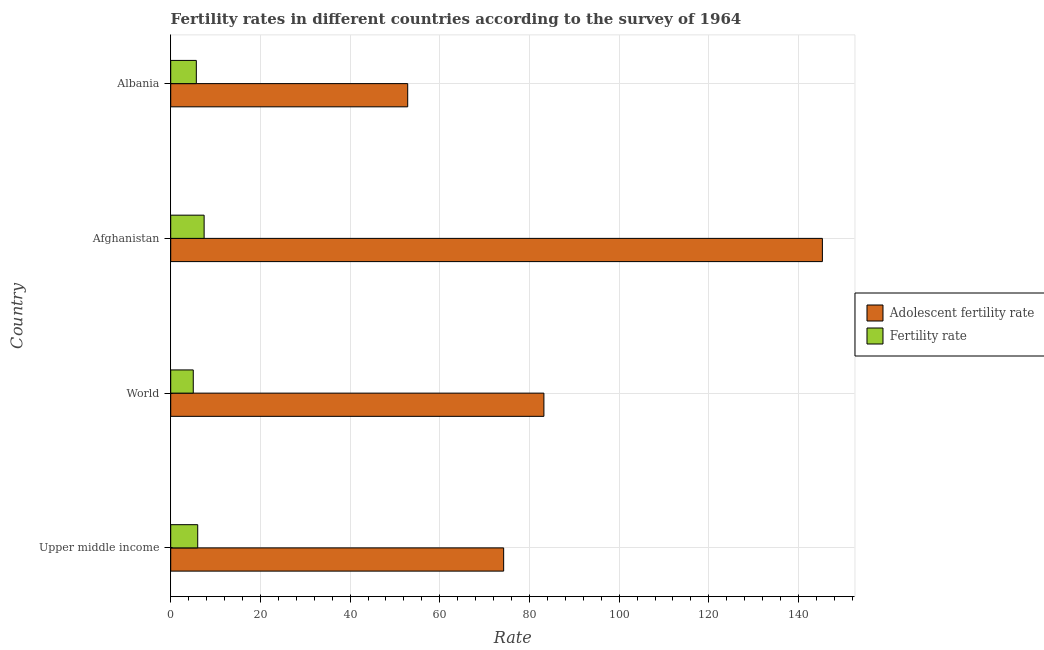How many different coloured bars are there?
Offer a terse response. 2. Are the number of bars per tick equal to the number of legend labels?
Your answer should be compact. Yes. What is the label of the 4th group of bars from the top?
Your answer should be compact. Upper middle income. What is the fertility rate in Albania?
Make the answer very short. 5.71. Across all countries, what is the maximum fertility rate?
Offer a terse response. 7.45. Across all countries, what is the minimum fertility rate?
Keep it short and to the point. 5.03. In which country was the fertility rate maximum?
Keep it short and to the point. Afghanistan. What is the total adolescent fertility rate in the graph?
Provide a short and direct response. 355.63. What is the difference between the adolescent fertility rate in Afghanistan and that in Upper middle income?
Give a very brief answer. 71.08. What is the difference between the fertility rate in World and the adolescent fertility rate in Albania?
Provide a succinct answer. -47.82. What is the average adolescent fertility rate per country?
Your answer should be very brief. 88.91. What is the difference between the fertility rate and adolescent fertility rate in Albania?
Keep it short and to the point. -47.13. What is the ratio of the adolescent fertility rate in Albania to that in World?
Give a very brief answer. 0.64. What is the difference between the highest and the second highest fertility rate?
Provide a short and direct response. 1.43. What is the difference between the highest and the lowest adolescent fertility rate?
Keep it short and to the point. 92.48. In how many countries, is the fertility rate greater than the average fertility rate taken over all countries?
Make the answer very short. 1. Is the sum of the fertility rate in Albania and World greater than the maximum adolescent fertility rate across all countries?
Offer a terse response. No. What does the 1st bar from the top in Albania represents?
Provide a short and direct response. Fertility rate. What does the 2nd bar from the bottom in Upper middle income represents?
Make the answer very short. Fertility rate. How many bars are there?
Offer a very short reply. 8. Are all the bars in the graph horizontal?
Keep it short and to the point. Yes. Does the graph contain any zero values?
Provide a short and direct response. No. How many legend labels are there?
Keep it short and to the point. 2. How are the legend labels stacked?
Your answer should be very brief. Vertical. What is the title of the graph?
Your answer should be very brief. Fertility rates in different countries according to the survey of 1964. Does "Register a property" appear as one of the legend labels in the graph?
Provide a succinct answer. No. What is the label or title of the X-axis?
Give a very brief answer. Rate. What is the label or title of the Y-axis?
Ensure brevity in your answer.  Country. What is the Rate in Adolescent fertility rate in Upper middle income?
Your answer should be very brief. 74.24. What is the Rate in Fertility rate in Upper middle income?
Offer a very short reply. 6.02. What is the Rate in Adolescent fertility rate in World?
Make the answer very short. 83.22. What is the Rate in Fertility rate in World?
Provide a short and direct response. 5.03. What is the Rate in Adolescent fertility rate in Afghanistan?
Offer a very short reply. 145.32. What is the Rate in Fertility rate in Afghanistan?
Offer a very short reply. 7.45. What is the Rate of Adolescent fertility rate in Albania?
Give a very brief answer. 52.85. What is the Rate in Fertility rate in Albania?
Offer a terse response. 5.71. Across all countries, what is the maximum Rate of Adolescent fertility rate?
Offer a terse response. 145.32. Across all countries, what is the maximum Rate of Fertility rate?
Ensure brevity in your answer.  7.45. Across all countries, what is the minimum Rate in Adolescent fertility rate?
Ensure brevity in your answer.  52.85. Across all countries, what is the minimum Rate of Fertility rate?
Your answer should be compact. 5.03. What is the total Rate of Adolescent fertility rate in the graph?
Give a very brief answer. 355.63. What is the total Rate of Fertility rate in the graph?
Provide a short and direct response. 24.21. What is the difference between the Rate in Adolescent fertility rate in Upper middle income and that in World?
Make the answer very short. -8.97. What is the difference between the Rate of Adolescent fertility rate in Upper middle income and that in Afghanistan?
Your answer should be very brief. -71.08. What is the difference between the Rate in Fertility rate in Upper middle income and that in Afghanistan?
Offer a terse response. -1.43. What is the difference between the Rate of Adolescent fertility rate in Upper middle income and that in Albania?
Your answer should be very brief. 21.4. What is the difference between the Rate of Fertility rate in Upper middle income and that in Albania?
Give a very brief answer. 0.31. What is the difference between the Rate of Adolescent fertility rate in World and that in Afghanistan?
Make the answer very short. -62.1. What is the difference between the Rate in Fertility rate in World and that in Afghanistan?
Provide a succinct answer. -2.42. What is the difference between the Rate in Adolescent fertility rate in World and that in Albania?
Offer a very short reply. 30.37. What is the difference between the Rate in Fertility rate in World and that in Albania?
Your answer should be very brief. -0.68. What is the difference between the Rate of Adolescent fertility rate in Afghanistan and that in Albania?
Provide a succinct answer. 92.47. What is the difference between the Rate of Fertility rate in Afghanistan and that in Albania?
Your response must be concise. 1.74. What is the difference between the Rate of Adolescent fertility rate in Upper middle income and the Rate of Fertility rate in World?
Provide a short and direct response. 69.22. What is the difference between the Rate in Adolescent fertility rate in Upper middle income and the Rate in Fertility rate in Afghanistan?
Your answer should be very brief. 66.79. What is the difference between the Rate of Adolescent fertility rate in Upper middle income and the Rate of Fertility rate in Albania?
Offer a terse response. 68.53. What is the difference between the Rate in Adolescent fertility rate in World and the Rate in Fertility rate in Afghanistan?
Provide a succinct answer. 75.77. What is the difference between the Rate of Adolescent fertility rate in World and the Rate of Fertility rate in Albania?
Your answer should be compact. 77.51. What is the difference between the Rate in Adolescent fertility rate in Afghanistan and the Rate in Fertility rate in Albania?
Offer a very short reply. 139.61. What is the average Rate in Adolescent fertility rate per country?
Offer a very short reply. 88.91. What is the average Rate in Fertility rate per country?
Offer a very short reply. 6.05. What is the difference between the Rate in Adolescent fertility rate and Rate in Fertility rate in Upper middle income?
Provide a succinct answer. 68.22. What is the difference between the Rate of Adolescent fertility rate and Rate of Fertility rate in World?
Your answer should be compact. 78.19. What is the difference between the Rate in Adolescent fertility rate and Rate in Fertility rate in Afghanistan?
Give a very brief answer. 137.87. What is the difference between the Rate in Adolescent fertility rate and Rate in Fertility rate in Albania?
Offer a very short reply. 47.13. What is the ratio of the Rate of Adolescent fertility rate in Upper middle income to that in World?
Keep it short and to the point. 0.89. What is the ratio of the Rate of Fertility rate in Upper middle income to that in World?
Give a very brief answer. 1.2. What is the ratio of the Rate of Adolescent fertility rate in Upper middle income to that in Afghanistan?
Make the answer very short. 0.51. What is the ratio of the Rate of Fertility rate in Upper middle income to that in Afghanistan?
Provide a succinct answer. 0.81. What is the ratio of the Rate of Adolescent fertility rate in Upper middle income to that in Albania?
Offer a very short reply. 1.4. What is the ratio of the Rate of Fertility rate in Upper middle income to that in Albania?
Your answer should be compact. 1.05. What is the ratio of the Rate in Adolescent fertility rate in World to that in Afghanistan?
Your response must be concise. 0.57. What is the ratio of the Rate of Fertility rate in World to that in Afghanistan?
Ensure brevity in your answer.  0.67. What is the ratio of the Rate of Adolescent fertility rate in World to that in Albania?
Ensure brevity in your answer.  1.57. What is the ratio of the Rate in Fertility rate in World to that in Albania?
Your response must be concise. 0.88. What is the ratio of the Rate of Adolescent fertility rate in Afghanistan to that in Albania?
Offer a very short reply. 2.75. What is the ratio of the Rate of Fertility rate in Afghanistan to that in Albania?
Provide a succinct answer. 1.3. What is the difference between the highest and the second highest Rate of Adolescent fertility rate?
Offer a terse response. 62.1. What is the difference between the highest and the second highest Rate of Fertility rate?
Your response must be concise. 1.43. What is the difference between the highest and the lowest Rate in Adolescent fertility rate?
Make the answer very short. 92.47. What is the difference between the highest and the lowest Rate of Fertility rate?
Your answer should be very brief. 2.42. 